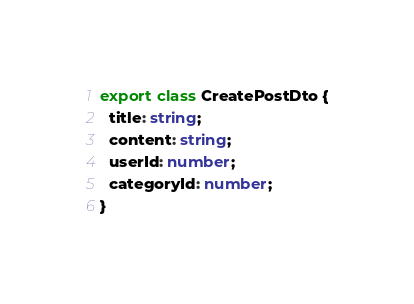Convert code to text. <code><loc_0><loc_0><loc_500><loc_500><_TypeScript_>export class CreatePostDto {
  title: string;
  content: string;
  userId: number;
  categoryId: number;
}</code> 